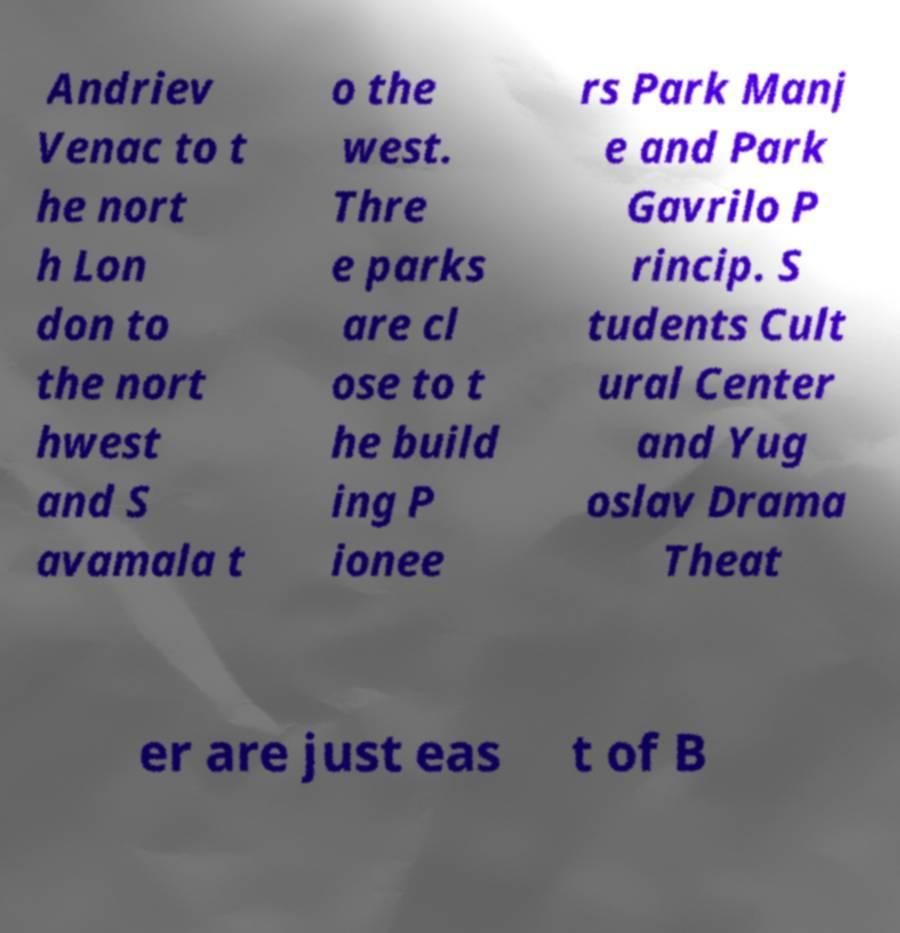What messages or text are displayed in this image? I need them in a readable, typed format. Andriev Venac to t he nort h Lon don to the nort hwest and S avamala t o the west. Thre e parks are cl ose to t he build ing P ionee rs Park Manj e and Park Gavrilo P rincip. S tudents Cult ural Center and Yug oslav Drama Theat er are just eas t of B 